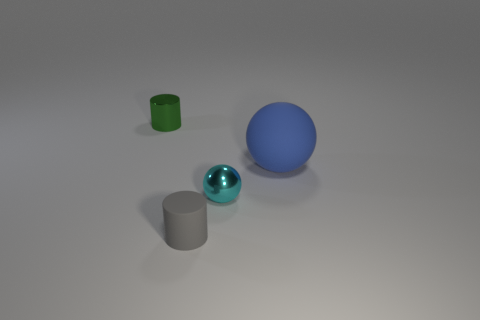What number of large matte spheres are in front of the rubber thing behind the tiny cylinder right of the green metal object?
Your answer should be compact. 0. There is a tiny cylinder that is the same material as the small sphere; what color is it?
Make the answer very short. Green. There is a cylinder behind the gray rubber cylinder; does it have the same size as the big blue matte object?
Your response must be concise. No. How many objects are blue spheres or tiny cylinders?
Provide a short and direct response. 3. There is a small cylinder that is in front of the small cylinder to the left of the rubber thing to the left of the blue rubber object; what is it made of?
Your answer should be compact. Rubber. There is a ball left of the large matte object; what is it made of?
Give a very brief answer. Metal. Is there a blue thing of the same size as the gray cylinder?
Offer a very short reply. No. Is the color of the tiny object that is in front of the cyan object the same as the rubber ball?
Provide a succinct answer. No. How many red things are balls or tiny cylinders?
Ensure brevity in your answer.  0. Do the cyan sphere and the green cylinder have the same material?
Offer a terse response. Yes. 